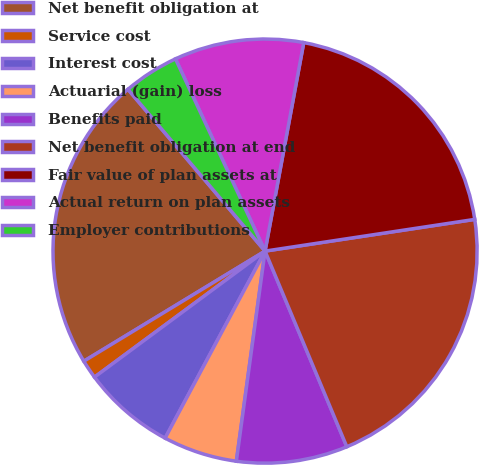Convert chart to OTSL. <chart><loc_0><loc_0><loc_500><loc_500><pie_chart><fcel>Net benefit obligation at<fcel>Service cost<fcel>Interest cost<fcel>Actuarial (gain) loss<fcel>Benefits paid<fcel>Net benefit obligation at end<fcel>Fair value of plan assets at<fcel>Actual return on plan assets<fcel>Employer contributions<nl><fcel>22.5%<fcel>1.44%<fcel>7.06%<fcel>5.65%<fcel>8.46%<fcel>21.09%<fcel>19.69%<fcel>9.86%<fcel>4.25%<nl></chart> 